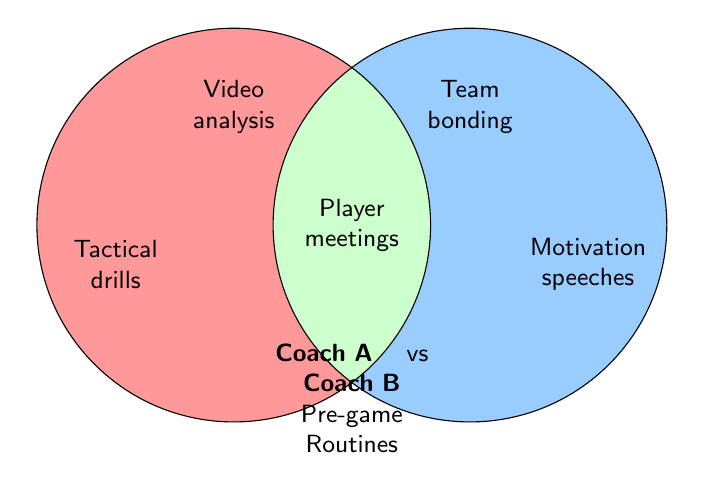What is the title of the Venn Diagram? The title is located at the bottom part of the diagram. By reading it, we can see it is "Coach A vs Coach B Pre-game Routines".
Answer: Coach A vs Coach B Pre-game Routines What color is used for Coach A's unique activities? Coach A's unique activities are in the left circle, filled with a shade of red.
Answer: Shade of red Which activity is common between Coach A and Coach B? The common activities are found in the overlapping region of the Venn Diagram. Among them, "Player meetings" appears in the center.
Answer: Player meetings How many unique activities does Coach A have, according to the Venn Diagram? By counting the unique activities listed in Coach A's circle, we can identify "Video analysis", "Tactical drills", "Opposition scouting", "Physical conditioning", and "Mental toughness training", totaling five.
Answer: 5 Compare the number of unique activities between Coach A and Coach B. Which coach has more unique activities? According to the Venn Diagram, both coaches have their unique activities listed in their respective circles. Coach A has five unique activities, while Coach B has five as well: "Team bonding", "Motivation speeches", "Visualization exercises", "Superstitious rituals", and "Relaxation techniques".
Answer: Both have the same Which activity does Coach B use that might psychologically prepare the players? Coach B uses activities towards the right side of the Venn Diagram. "Visualization exercises" and "Relaxation techniques" are activities that appear to prepare players psychologically.
Answer: Visualization exercises, Relaxation techniques Are there any activities related specifically to physical training? If so, which ones? Reviewing both circles, "Physical conditioning" in Coach A's and "Relaxation techniques" in Coach B's are related to physical aspects, specific to training.
Answer: Physical conditioning, Relaxation techniques How does the color scheme differentiate between unique activities and common activities? The unique activities for each coach are colored differently (shade of red for Coach A and shade of blue for Coach B), while the common activities are in a shade of green.
Answer: Red, Blue, Green List the activities that Coach A and Coach B both use. The activities in the overlapping region of the Venn Diagram are common to both coaches. The listed common activities are "Player meetings", "Game plan review", "Team walk-through", "Media preparation", "Equipment check".
Answer: Player meetings, Game plan review, Team walk-through, Media preparation, Equipment check 